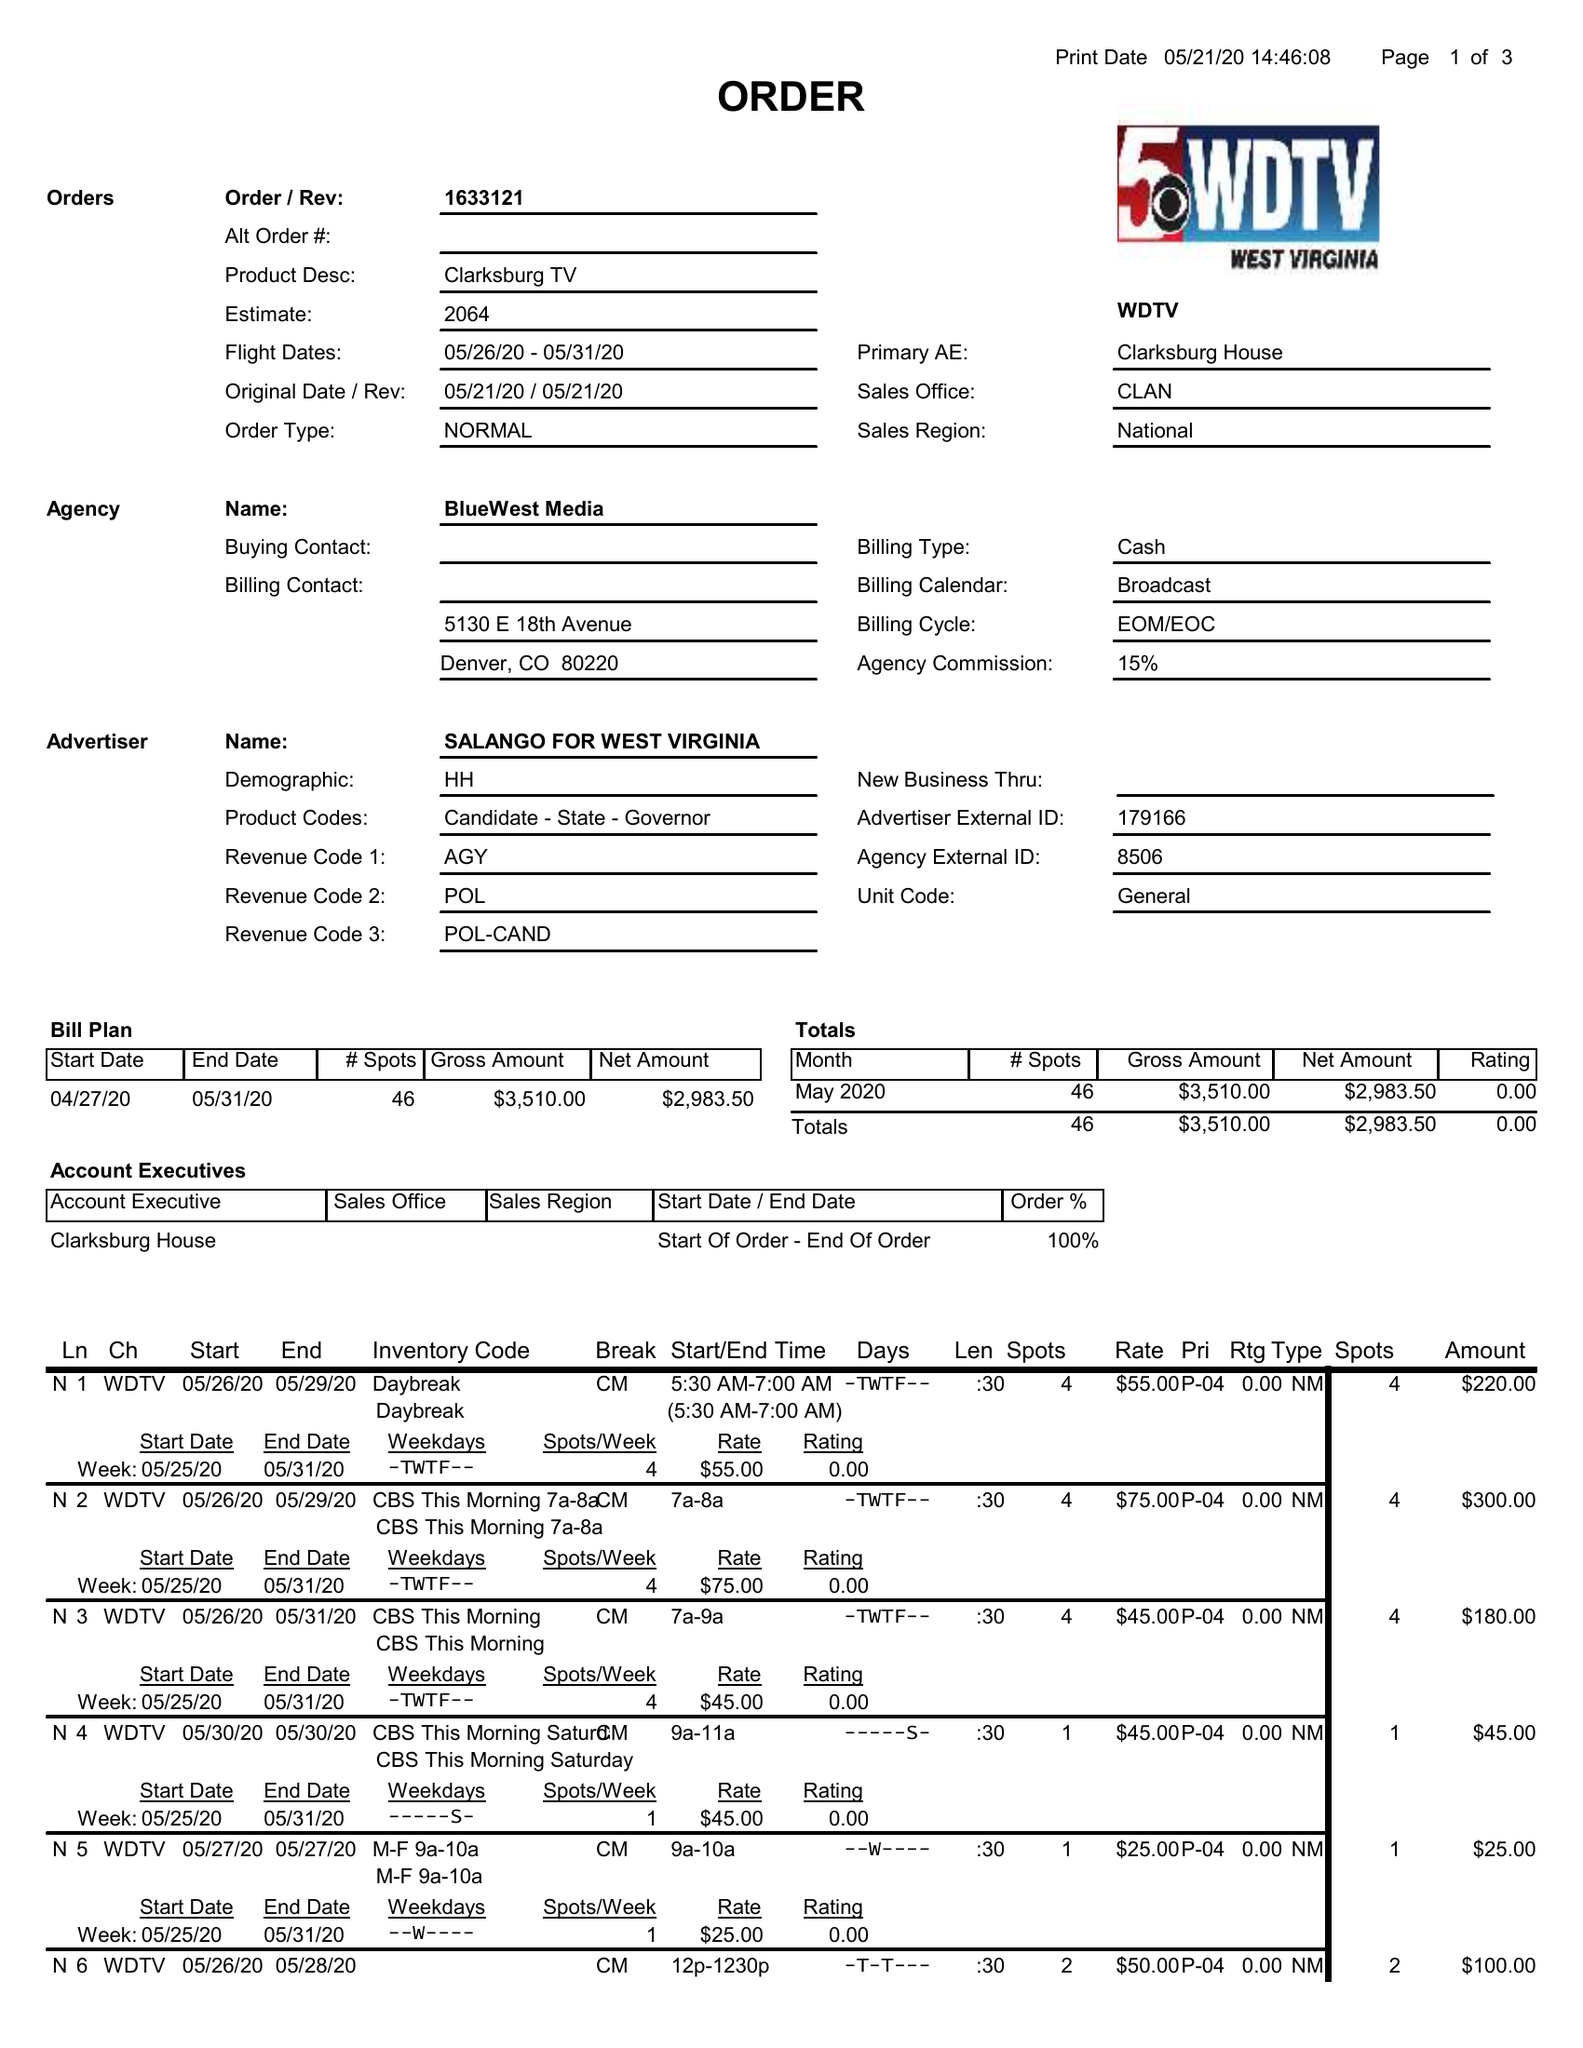What is the value for the flight_from?
Answer the question using a single word or phrase. 05/26/20 